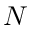<formula> <loc_0><loc_0><loc_500><loc_500>N</formula> 